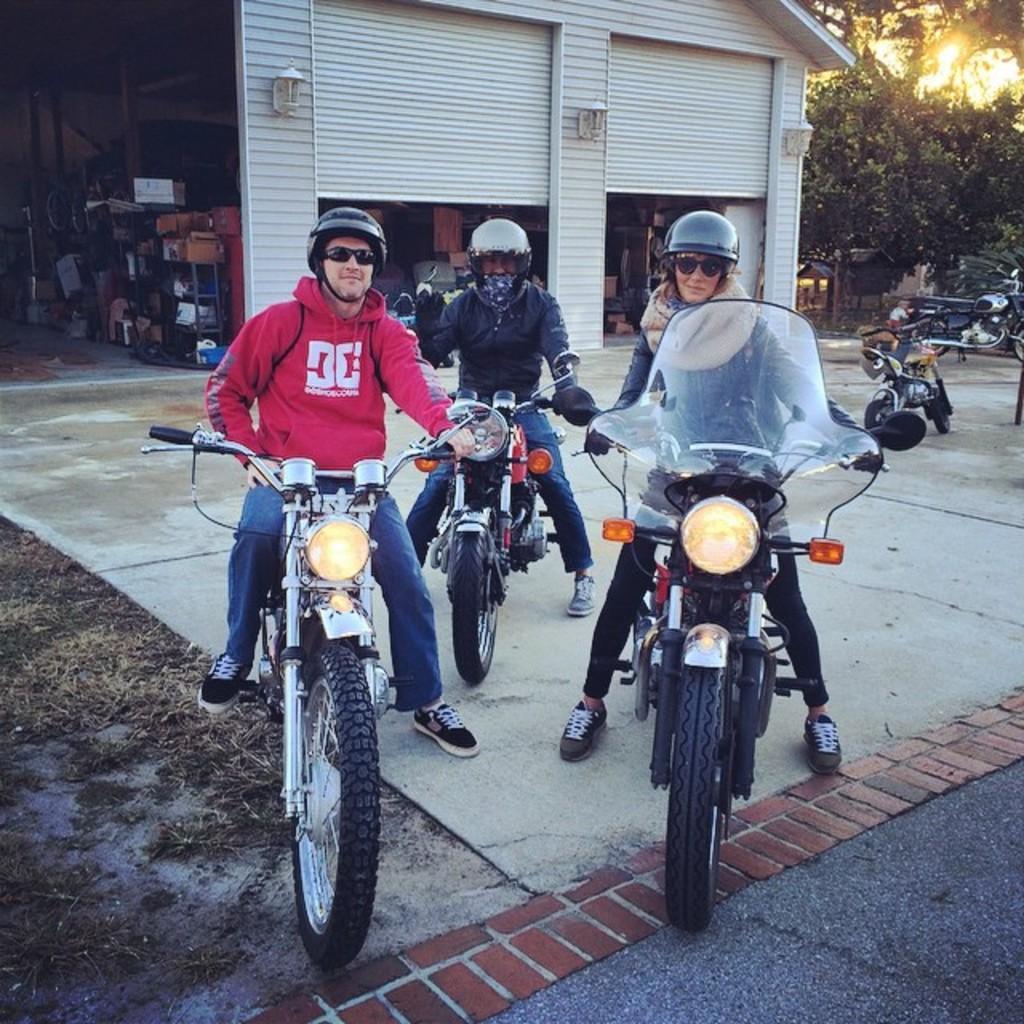Can you describe this image briefly? In this image i can see three persons riding bike on the road at the back ground i can see a building, and a light and a tree. 